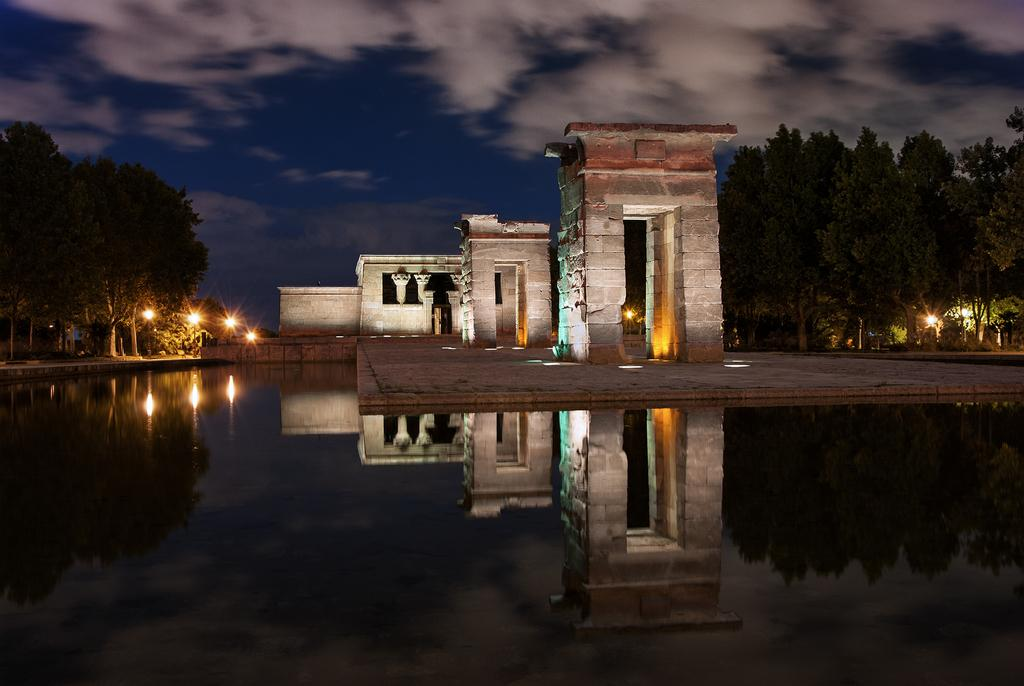What is in the foreground of the image? There is a water body in the foreground of the image. What can be seen in the middle of the image? Trees, a street light, a road, and a construction are visible in the middle of the image. What is the condition of the sky in the image? The sky is visible at the top of the image. What type of texture can be seen on the sock in the image? There is no sock present in the image. What type of crime is being committed in the image? There is no crime being committed in the image. 